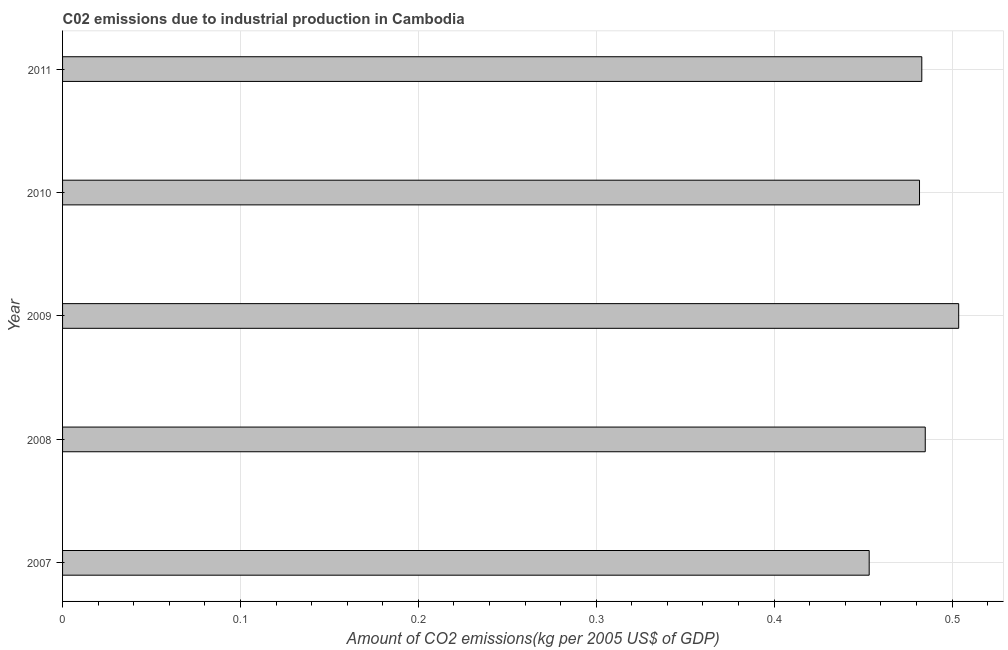Does the graph contain any zero values?
Provide a succinct answer. No. Does the graph contain grids?
Offer a terse response. Yes. What is the title of the graph?
Provide a succinct answer. C02 emissions due to industrial production in Cambodia. What is the label or title of the X-axis?
Ensure brevity in your answer.  Amount of CO2 emissions(kg per 2005 US$ of GDP). What is the amount of co2 emissions in 2010?
Provide a succinct answer. 0.48. Across all years, what is the maximum amount of co2 emissions?
Offer a terse response. 0.5. Across all years, what is the minimum amount of co2 emissions?
Provide a short and direct response. 0.45. What is the sum of the amount of co2 emissions?
Provide a short and direct response. 2.41. What is the difference between the amount of co2 emissions in 2008 and 2009?
Make the answer very short. -0.02. What is the average amount of co2 emissions per year?
Provide a short and direct response. 0.48. What is the median amount of co2 emissions?
Offer a terse response. 0.48. In how many years, is the amount of co2 emissions greater than 0.32 kg per 2005 US$ of GDP?
Keep it short and to the point. 5. What is the ratio of the amount of co2 emissions in 2009 to that in 2011?
Provide a short and direct response. 1.04. Is the amount of co2 emissions in 2010 less than that in 2011?
Make the answer very short. Yes. Is the difference between the amount of co2 emissions in 2008 and 2010 greater than the difference between any two years?
Keep it short and to the point. No. What is the difference between the highest and the second highest amount of co2 emissions?
Provide a short and direct response. 0.02. What is the difference between the highest and the lowest amount of co2 emissions?
Your answer should be compact. 0.05. How many bars are there?
Make the answer very short. 5. How many years are there in the graph?
Offer a terse response. 5. Are the values on the major ticks of X-axis written in scientific E-notation?
Ensure brevity in your answer.  No. What is the Amount of CO2 emissions(kg per 2005 US$ of GDP) in 2007?
Offer a very short reply. 0.45. What is the Amount of CO2 emissions(kg per 2005 US$ of GDP) in 2008?
Offer a terse response. 0.48. What is the Amount of CO2 emissions(kg per 2005 US$ of GDP) of 2009?
Offer a very short reply. 0.5. What is the Amount of CO2 emissions(kg per 2005 US$ of GDP) in 2010?
Give a very brief answer. 0.48. What is the Amount of CO2 emissions(kg per 2005 US$ of GDP) of 2011?
Your response must be concise. 0.48. What is the difference between the Amount of CO2 emissions(kg per 2005 US$ of GDP) in 2007 and 2008?
Offer a terse response. -0.03. What is the difference between the Amount of CO2 emissions(kg per 2005 US$ of GDP) in 2007 and 2009?
Provide a succinct answer. -0.05. What is the difference between the Amount of CO2 emissions(kg per 2005 US$ of GDP) in 2007 and 2010?
Offer a terse response. -0.03. What is the difference between the Amount of CO2 emissions(kg per 2005 US$ of GDP) in 2007 and 2011?
Offer a terse response. -0.03. What is the difference between the Amount of CO2 emissions(kg per 2005 US$ of GDP) in 2008 and 2009?
Your answer should be very brief. -0.02. What is the difference between the Amount of CO2 emissions(kg per 2005 US$ of GDP) in 2008 and 2010?
Offer a terse response. 0. What is the difference between the Amount of CO2 emissions(kg per 2005 US$ of GDP) in 2008 and 2011?
Provide a succinct answer. 0. What is the difference between the Amount of CO2 emissions(kg per 2005 US$ of GDP) in 2009 and 2010?
Keep it short and to the point. 0.02. What is the difference between the Amount of CO2 emissions(kg per 2005 US$ of GDP) in 2009 and 2011?
Offer a very short reply. 0.02. What is the difference between the Amount of CO2 emissions(kg per 2005 US$ of GDP) in 2010 and 2011?
Your response must be concise. -0. What is the ratio of the Amount of CO2 emissions(kg per 2005 US$ of GDP) in 2007 to that in 2008?
Give a very brief answer. 0.94. What is the ratio of the Amount of CO2 emissions(kg per 2005 US$ of GDP) in 2007 to that in 2009?
Offer a very short reply. 0.9. What is the ratio of the Amount of CO2 emissions(kg per 2005 US$ of GDP) in 2007 to that in 2010?
Provide a succinct answer. 0.94. What is the ratio of the Amount of CO2 emissions(kg per 2005 US$ of GDP) in 2007 to that in 2011?
Offer a very short reply. 0.94. What is the ratio of the Amount of CO2 emissions(kg per 2005 US$ of GDP) in 2008 to that in 2009?
Provide a succinct answer. 0.96. What is the ratio of the Amount of CO2 emissions(kg per 2005 US$ of GDP) in 2008 to that in 2010?
Provide a short and direct response. 1.01. What is the ratio of the Amount of CO2 emissions(kg per 2005 US$ of GDP) in 2009 to that in 2010?
Your answer should be very brief. 1.05. What is the ratio of the Amount of CO2 emissions(kg per 2005 US$ of GDP) in 2009 to that in 2011?
Ensure brevity in your answer.  1.04. What is the ratio of the Amount of CO2 emissions(kg per 2005 US$ of GDP) in 2010 to that in 2011?
Provide a succinct answer. 1. 